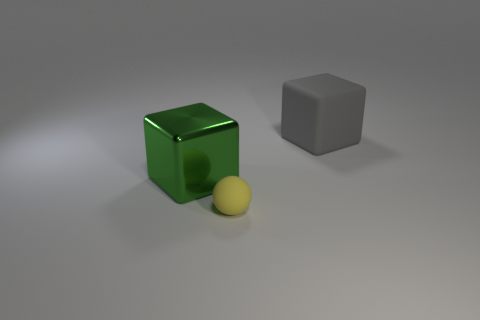Add 2 big yellow rubber objects. How many objects exist? 5 Subtract all green blocks. How many blocks are left? 1 Subtract 0 yellow cylinders. How many objects are left? 3 Subtract all balls. How many objects are left? 2 Subtract all green balls. Subtract all blue blocks. How many balls are left? 1 Subtract all purple cylinders. How many gray balls are left? 0 Subtract all matte spheres. Subtract all blue metallic things. How many objects are left? 2 Add 3 green metal cubes. How many green metal cubes are left? 4 Add 1 big objects. How many big objects exist? 3 